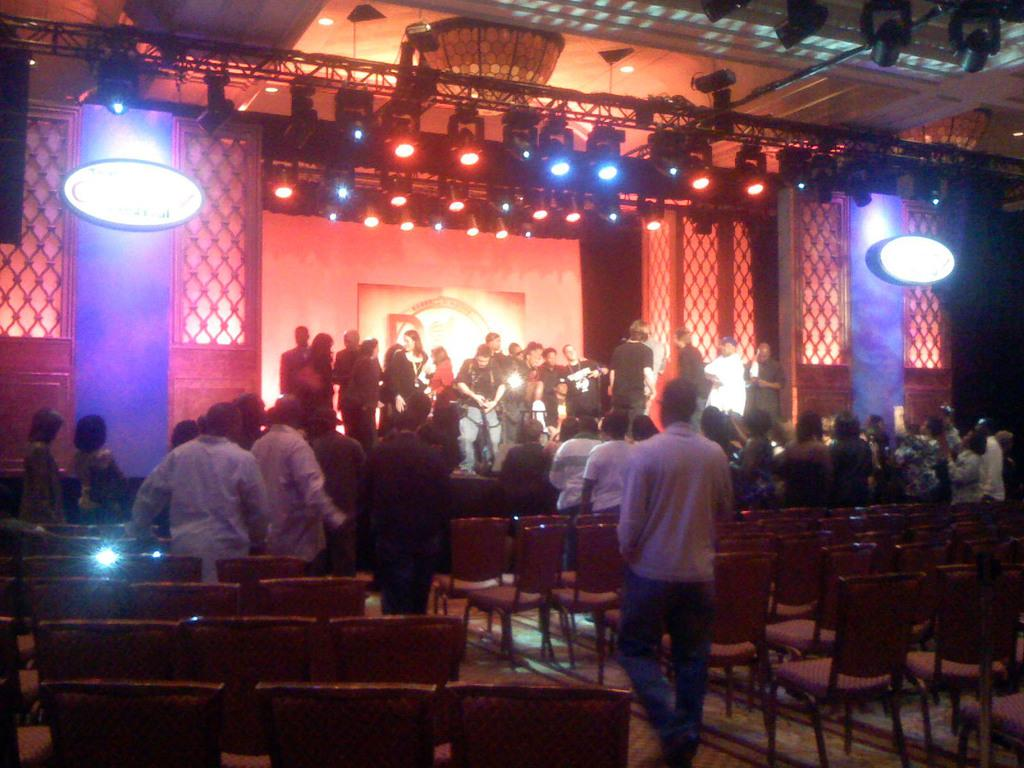How many people are in the image? There is a group of people in the image. What is on the ground that the people might sit on? There are chairs on the ground in the image. What can be seen in the distance in the image? There are lights visible in the background of the image. What else is present in the background of the image? There are some objects in the background of the image. Are there any babies in the image? There is no mention of a baby in the image, so we cannot confirm its presence. 